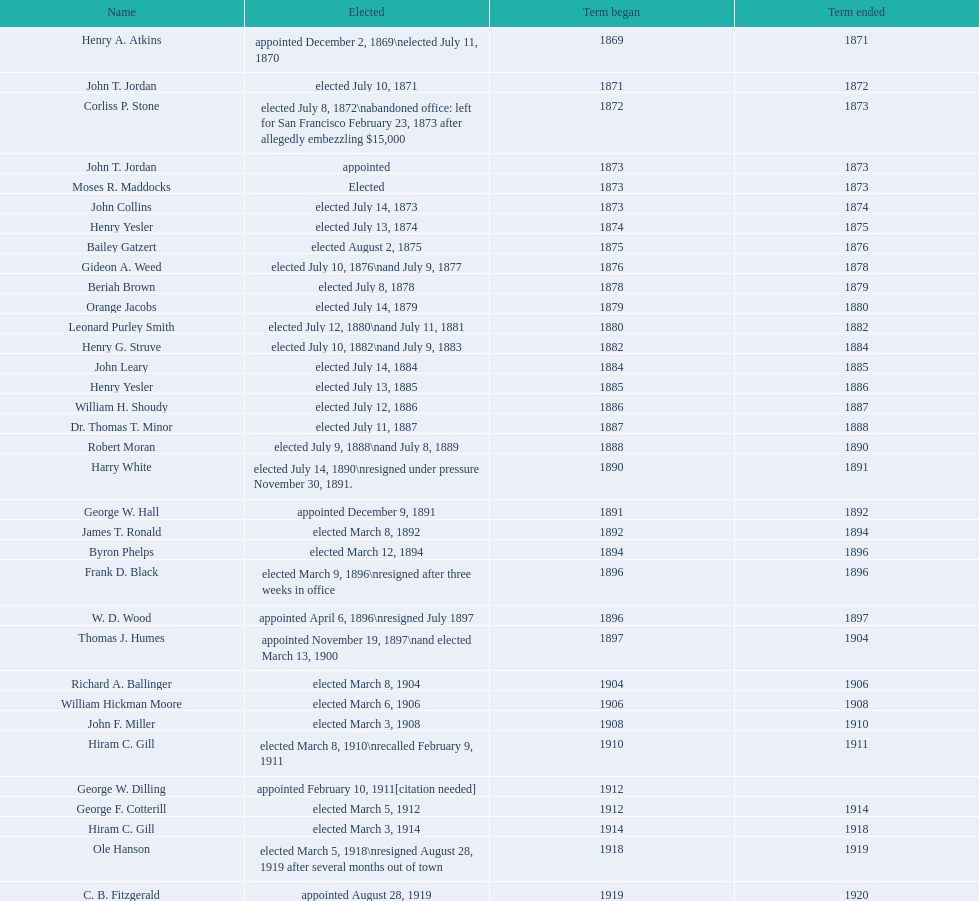Could you help me parse every detail presented in this table? {'header': ['Name', 'Elected', 'Term began', 'Term ended'], 'rows': [['Henry A. Atkins', 'appointed December 2, 1869\\nelected July 11, 1870', '1869', '1871'], ['John T. Jordan', 'elected July 10, 1871', '1871', '1872'], ['Corliss P. Stone', 'elected July 8, 1872\\nabandoned office: left for San Francisco February 23, 1873 after allegedly embezzling $15,000', '1872', '1873'], ['John T. Jordan', 'appointed', '1873', '1873'], ['Moses R. Maddocks', 'Elected', '1873', '1873'], ['John Collins', 'elected July 14, 1873', '1873', '1874'], ['Henry Yesler', 'elected July 13, 1874', '1874', '1875'], ['Bailey Gatzert', 'elected August 2, 1875', '1875', '1876'], ['Gideon A. Weed', 'elected July 10, 1876\\nand July 9, 1877', '1876', '1878'], ['Beriah Brown', 'elected July 8, 1878', '1878', '1879'], ['Orange Jacobs', 'elected July 14, 1879', '1879', '1880'], ['Leonard Purley Smith', 'elected July 12, 1880\\nand July 11, 1881', '1880', '1882'], ['Henry G. Struve', 'elected July 10, 1882\\nand July 9, 1883', '1882', '1884'], ['John Leary', 'elected July 14, 1884', '1884', '1885'], ['Henry Yesler', 'elected July 13, 1885', '1885', '1886'], ['William H. Shoudy', 'elected July 12, 1886', '1886', '1887'], ['Dr. Thomas T. Minor', 'elected July 11, 1887', '1887', '1888'], ['Robert Moran', 'elected July 9, 1888\\nand July 8, 1889', '1888', '1890'], ['Harry White', 'elected July 14, 1890\\nresigned under pressure November 30, 1891.', '1890', '1891'], ['George W. Hall', 'appointed December 9, 1891', '1891', '1892'], ['James T. Ronald', 'elected March 8, 1892', '1892', '1894'], ['Byron Phelps', 'elected March 12, 1894', '1894', '1896'], ['Frank D. Black', 'elected March 9, 1896\\nresigned after three weeks in office', '1896', '1896'], ['W. D. Wood', 'appointed April 6, 1896\\nresigned July 1897', '1896', '1897'], ['Thomas J. Humes', 'appointed November 19, 1897\\nand elected March 13, 1900', '1897', '1904'], ['Richard A. Ballinger', 'elected March 8, 1904', '1904', '1906'], ['William Hickman Moore', 'elected March 6, 1906', '1906', '1908'], ['John F. Miller', 'elected March 3, 1908', '1908', '1910'], ['Hiram C. Gill', 'elected March 8, 1910\\nrecalled February 9, 1911', '1910', '1911'], ['George W. Dilling', 'appointed February 10, 1911[citation needed]', '1912', ''], ['George F. Cotterill', 'elected March 5, 1912', '1912', '1914'], ['Hiram C. Gill', 'elected March 3, 1914', '1914', '1918'], ['Ole Hanson', 'elected March 5, 1918\\nresigned August 28, 1919 after several months out of town', '1918', '1919'], ['C. B. Fitzgerald', 'appointed August 28, 1919', '1919', '1920'], ['Hugh M. Caldwell', 'elected March 2, 1920', '1920', '1922'], ['Edwin J. Brown', 'elected May 2, 1922\\nand March 4, 1924', '1922', '1926'], ['Bertha Knight Landes', 'elected March 9, 1926', '1926', '1928'], ['Frank E. Edwards', 'elected March 6, 1928\\nand March 4, 1930\\nrecalled July 13, 1931', '1928', '1931'], ['Robert H. Harlin', 'appointed July 14, 1931', '1931', '1932'], ['John F. Dore', 'elected March 8, 1932', '1932', '1934'], ['Charles L. Smith', 'elected March 6, 1934', '1934', '1936'], ['John F. Dore', 'elected March 3, 1936\\nbecame gravely ill and was relieved of office April 13, 1938, already a lame duck after the 1938 election. He died five days later.', '1936', '1938'], ['Arthur B. Langlie', "elected March 8, 1938\\nappointed to take office early, April 27, 1938, after Dore's death.\\nelected March 5, 1940\\nresigned January 11, 1941, to become Governor of Washington", '1938', '1941'], ['John E. Carroll', 'appointed January 27, 1941', '1941', '1941'], ['Earl Millikin', 'elected March 4, 1941', '1941', '1942'], ['William F. Devin', 'elected March 3, 1942, March 7, 1944, March 5, 1946, and March 2, 1948', '1942', '1952'], ['Allan Pomeroy', 'elected March 4, 1952', '1952', '1956'], ['Gordon S. Clinton', 'elected March 6, 1956\\nand March 8, 1960', '1956', '1964'], ["James d'Orma Braman", 'elected March 10, 1964\\nresigned March 23, 1969, to accept an appointment as an Assistant Secretary in the Department of Transportation in the Nixon administration.', '1964', '1969'], ['Floyd C. Miller', 'appointed March 23, 1969', '1969', '1969'], ['Wesley C. Uhlman', 'elected November 4, 1969\\nand November 6, 1973\\nsurvived recall attempt on July 1, 1975', 'December 1, 1969', 'January 1, 1978'], ['Charles Royer', 'elected November 8, 1977, November 3, 1981, and November 5, 1985', 'January 1, 1978', 'January 1, 1990'], ['Norman B. Rice', 'elected November 7, 1989', 'January 1, 1990', 'January 1, 1998'], ['Paul Schell', 'elected November 4, 1997', 'January 1, 1998', 'January 1, 2002'], ['Gregory J. Nickels', 'elected November 6, 2001\\nand November 8, 2005', 'January 1, 2002', 'January 1, 2010'], ['Michael McGinn', 'elected November 3, 2009', 'January 1, 2010', 'January 1, 2014'], ['Ed Murray', 'elected November 5, 2013', 'January 1, 2014', 'present']]} Who was mayor of seattle, washington before being appointed to department of transportation during the nixon administration? James d'Orma Braman. 